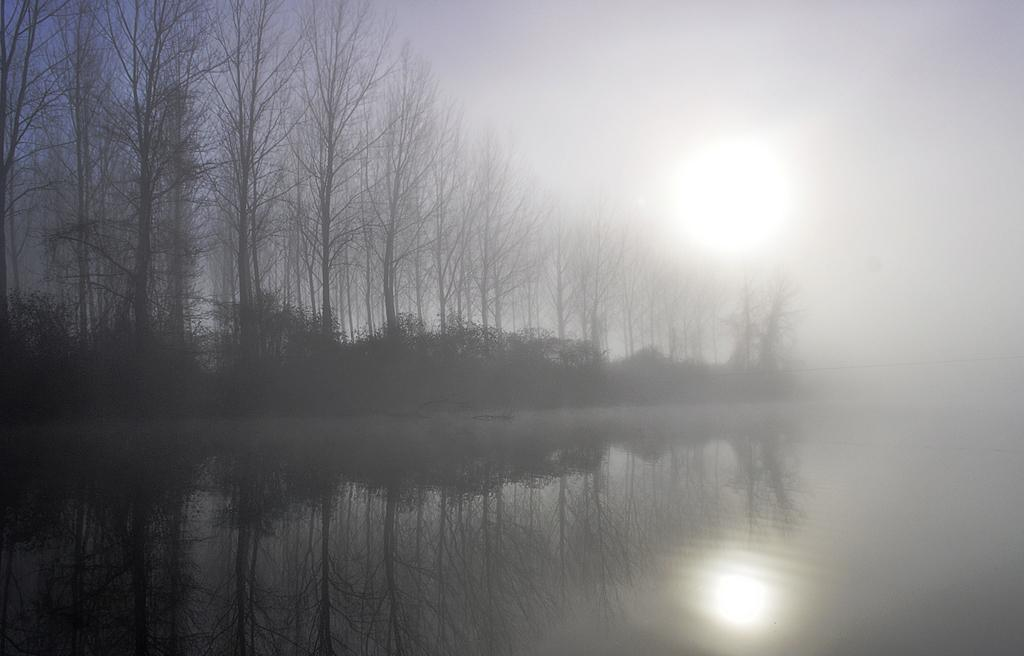What is at the bottom of the image? There is a surface of water at the bottom of the image. What can be seen in the middle of the image? Trees are present in the middle of the image. What is visible in the background of the image? The sky is visible in the background of the image. What color is the balloon floating in the sky in the image? There is no balloon present in the image; only the surface of water, trees, and the sky are visible. What type of fuel is being used by the trees in the image? Trees do not use fuel; they produce their own energy through photosynthesis. 